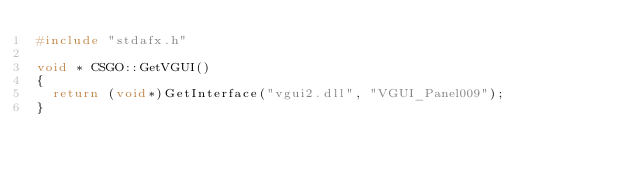Convert code to text. <code><loc_0><loc_0><loc_500><loc_500><_C++_>#include "stdafx.h"

void * CSGO::GetVGUI()
{
	return (void*)GetInterface("vgui2.dll", "VGUI_Panel009");
}
</code> 